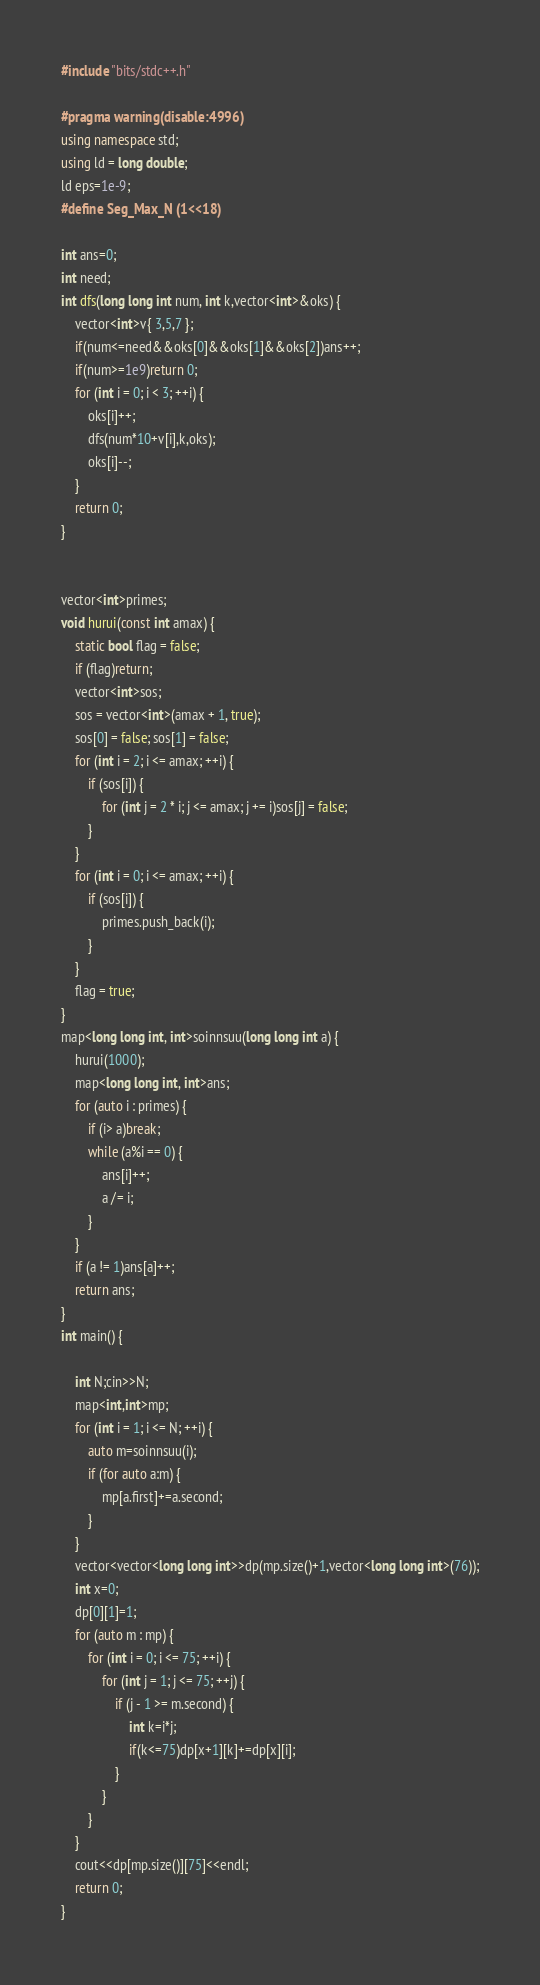<code> <loc_0><loc_0><loc_500><loc_500><_C++_>#include "bits/stdc++.h"

#pragma warning(disable:4996)
using namespace std;
using ld = long double;
ld eps=1e-9;
#define Seg_Max_N (1<<18) 

int ans=0;
int need;
int dfs(long long int num, int k,vector<int>&oks) {
	vector<int>v{ 3,5,7 };
	if(num<=need&&oks[0]&&oks[1]&&oks[2])ans++;
	if(num>=1e9)return 0;
	for (int i = 0; i < 3; ++i) {
		oks[i]++;
		dfs(num*10+v[i],k,oks);
		oks[i]--;
	}
	return 0;
}


vector<int>primes;
void hurui(const int amax) {
	static bool flag = false;
	if (flag)return;
	vector<int>sos;
	sos = vector<int>(amax + 1, true);
	sos[0] = false; sos[1] = false;
	for (int i = 2; i <= amax; ++i) {
		if (sos[i]) {
			for (int j = 2 * i; j <= amax; j += i)sos[j] = false;
		}
	}
	for (int i = 0; i <= amax; ++i) {
		if (sos[i]) {
			primes.push_back(i);
		}
	}
	flag = true;
}
map<long long int, int>soinnsuu(long long int a) {
	hurui(1000);
	map<long long int, int>ans;
	for (auto i : primes) {
		if (i> a)break;
		while (a%i == 0) {
			ans[i]++;
			a /= i;
		}
	}
	if (a != 1)ans[a]++;
	return ans;
}
int main() {

	int N;cin>>N;
	map<int,int>mp;
	for (int i = 1; i <= N; ++i) {
		auto m=soinnsuu(i);
		if (for auto a:m) {
			mp[a.first]+=a.second;
		}
	}
	vector<vector<long long int>>dp(mp.size()+1,vector<long long int>(76));
	int x=0;
	dp[0][1]=1;
	for (auto m : mp) {
		for (int i = 0; i <= 75; ++i) {
			for (int j = 1; j <= 75; ++j) {
				if (j - 1 >= m.second) {
					int k=i*j;
					if(k<=75)dp[x+1][k]+=dp[x][i];
				}
			}
		}
	}
	cout<<dp[mp.size()][75]<<endl;
	return 0;
}</code> 